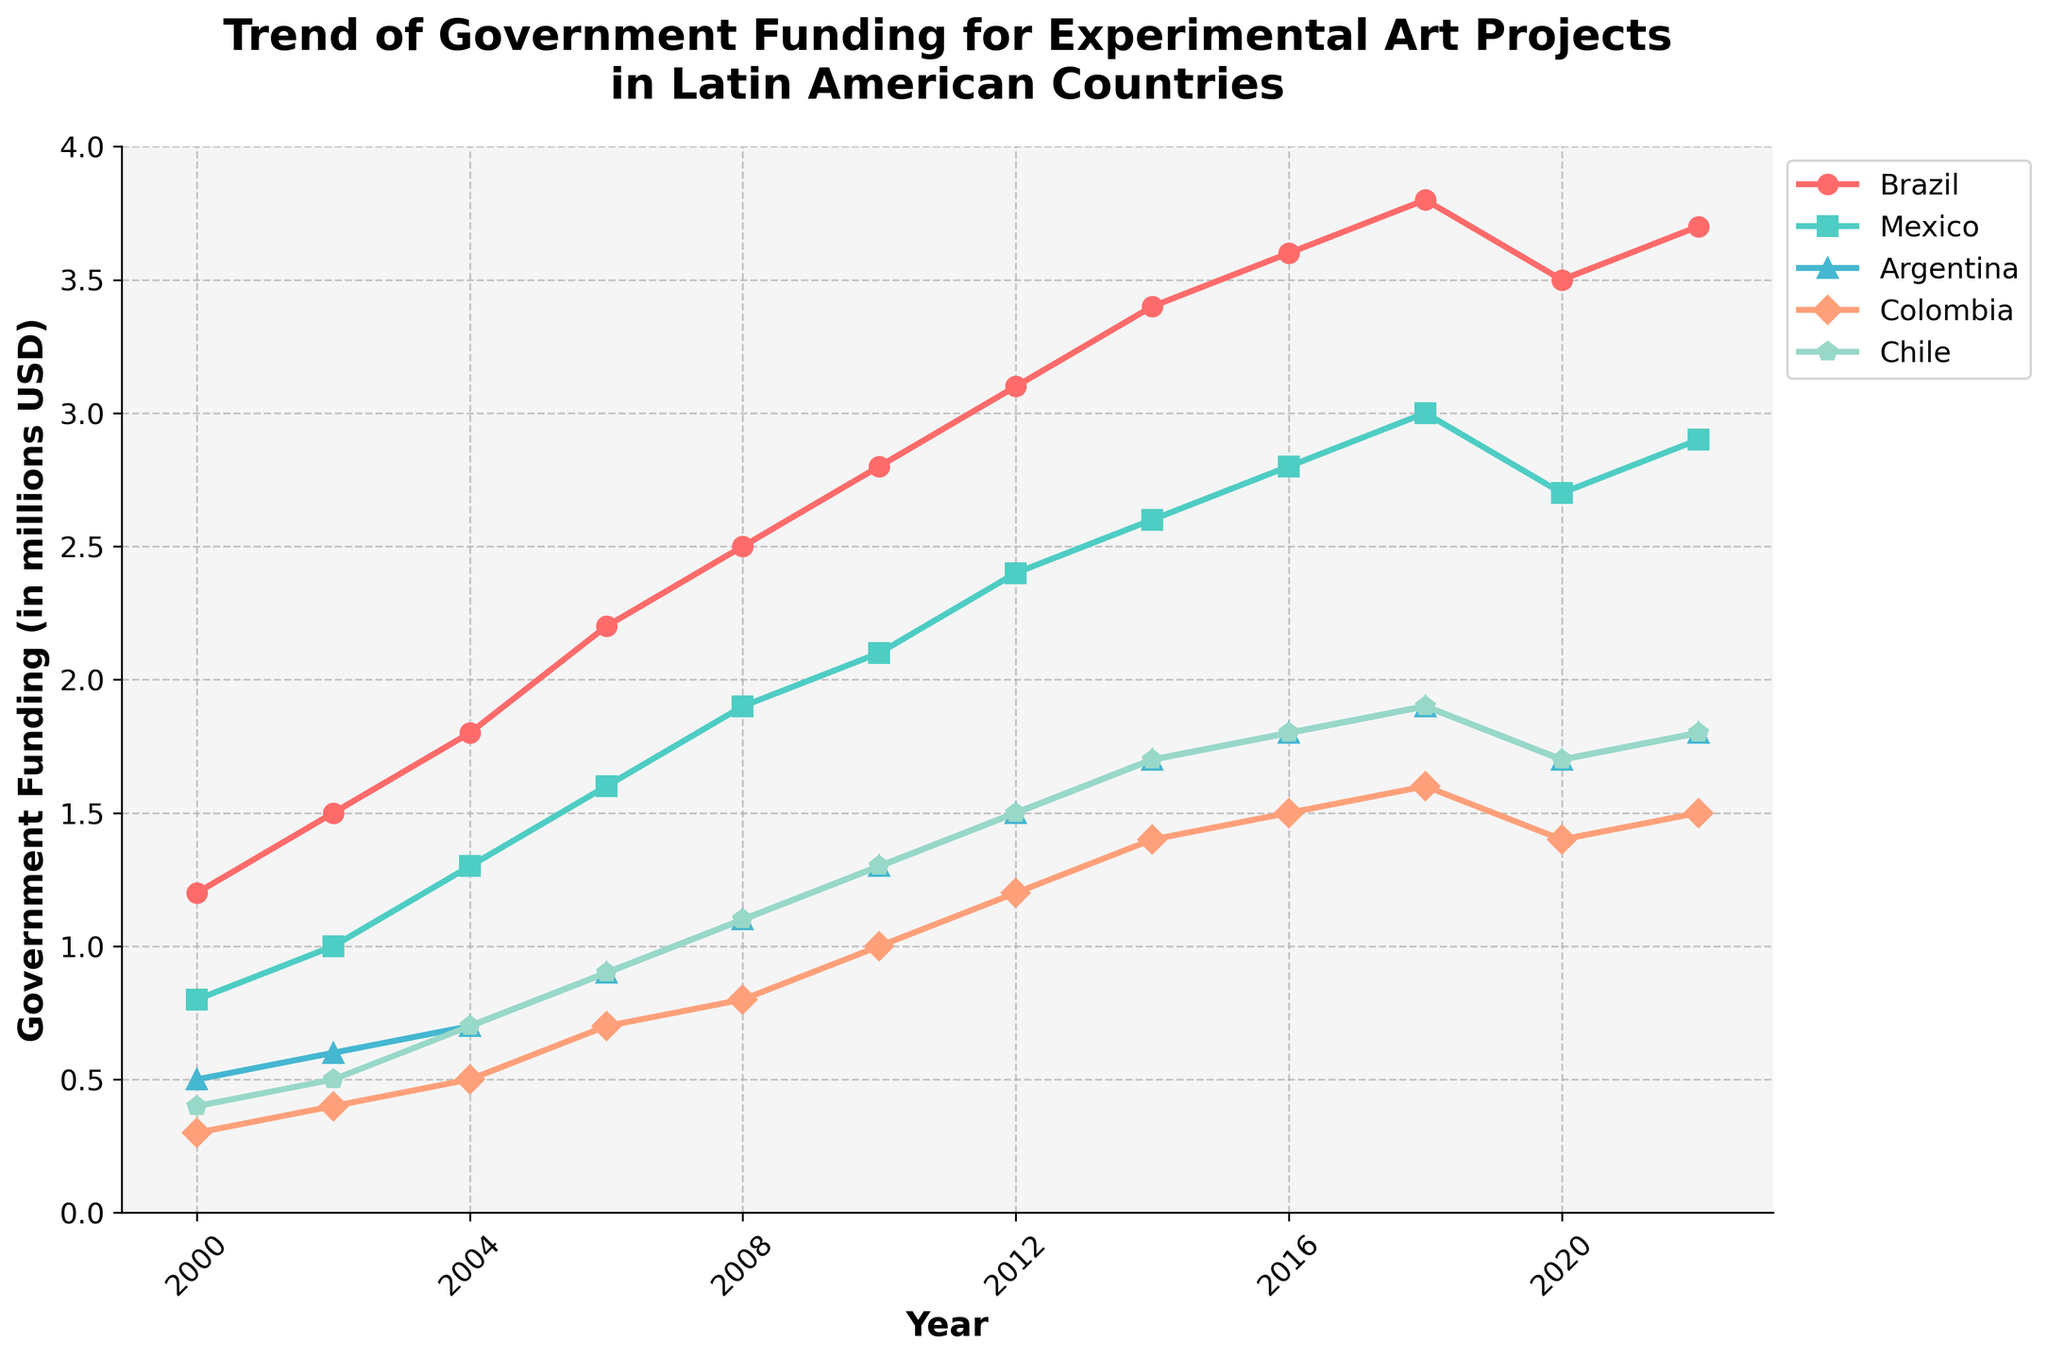What year did Brazil's government funding for experimental art projects reach 3 million USD for the first time? The line for Brazil intersects the 3 million USD mark for the first time around the year 2012.
Answer: 2012 Which country had the lowest funding in 2000, and how much was it? In 2000, Colombia had the lowest funding with a value of 0.3 million USD, which is the lowest point on the line chart.
Answer: Colombia, 0.3 million USD By how much did Chile's funding increase from 2000 to 2022? Chile's funding in 2000 was 0.4 million USD and increased to 1.8 million USD by 2022. The increase is 1.8 - 0.4 = 1.4 million USD.
Answer: 1.4 million USD Comparing 2010 and 2016, which country had the largest increase in government funding? Brazil's funding increased from 2.8 million USD in 2010 to 3.6 million USD in 2016, an increase of 0.8 million USD. No other country in the chart shows a larger increase than this.
Answer: Brazil In which year did Argentina have the smallest difference in funding compared to Mexico? Argentina and Mexico have the smallest difference in 2000, where the difference between 0.5 and 0.8 million USD is 0.3 million USD. The difference becomes larger in all subsequent years.
Answer: 2000 What is the average funding for Colombia from 2000 to 2022? Sum the funds for Colombia across 12 data points: 0.3 + 0.4 + 0.5 + 0.7 + 0.8 + 1.0 + 1.2 + 1.4 + 1.5 + 1.6 + 1.4 + 1.5 = 12.3. The average is 12.3 / 12 = 1.025 million USD.
Answer: 1.025 million USD Which two countries showed a decrease in funding from 2018 to 2020? From 2018 to 2020, the funding for Brazil decreased from 3.8 to 3.5 million USD and Mexico decreased from 3.0 to 2.7 million USD.
Answer: Brazil and Mexico In which year did both Chile and Argentina have the same amount of funding? From the chart, both Chile and Argentina have the same funding of 1.8 million USD in 2022.
Answer: 2022 